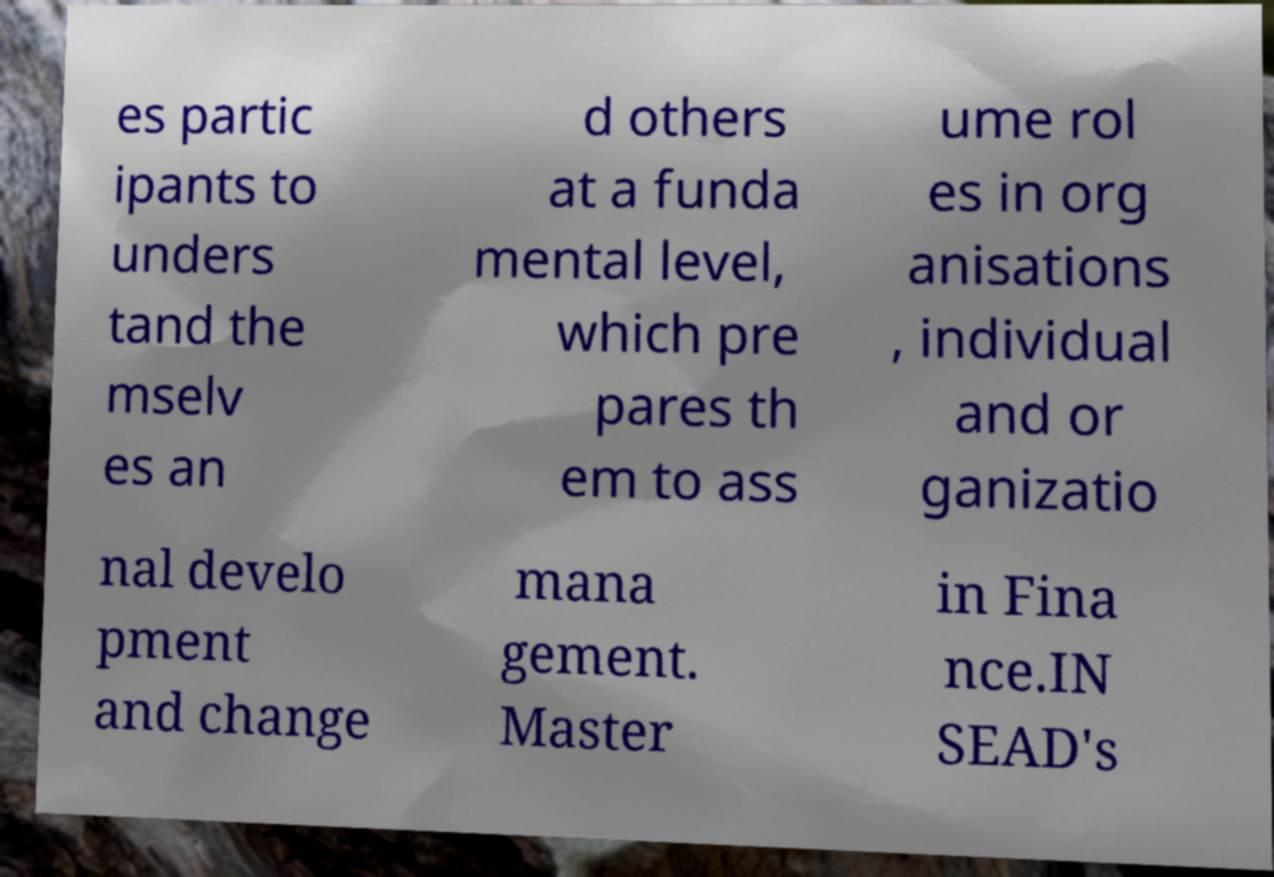Can you accurately transcribe the text from the provided image for me? es partic ipants to unders tand the mselv es an d others at a funda mental level, which pre pares th em to ass ume rol es in org anisations , individual and or ganizatio nal develo pment and change mana gement. Master in Fina nce.IN SEAD's 